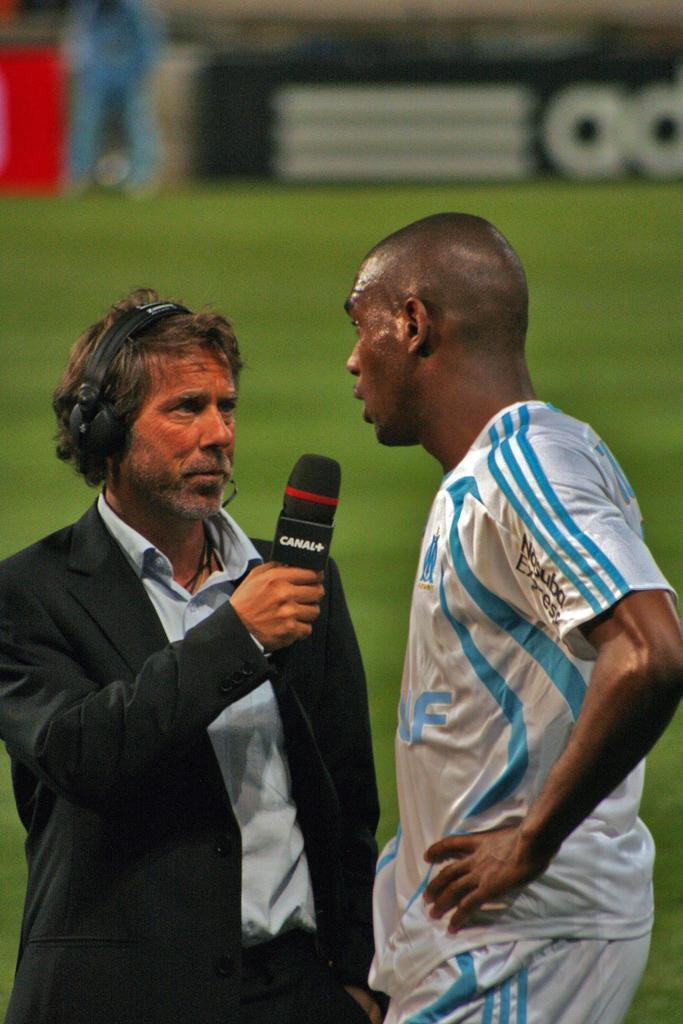Please provide a concise description of this image. This 2 persons are standing. This person wore black jacket is holding a mic. Far there is a grass in green color and a advertisement board. 